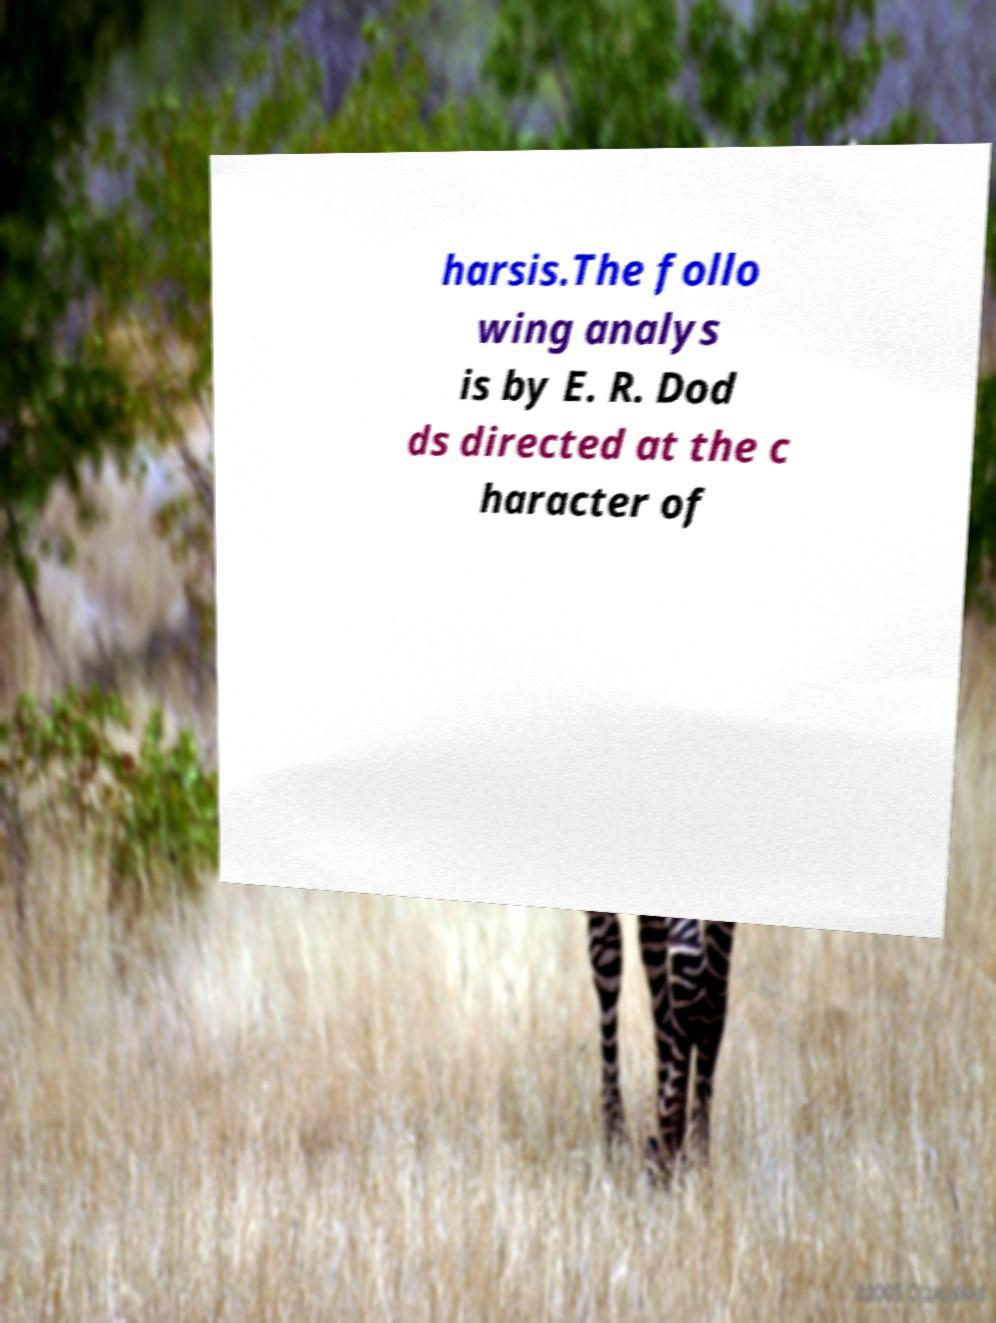Please read and relay the text visible in this image. What does it say? harsis.The follo wing analys is by E. R. Dod ds directed at the c haracter of 